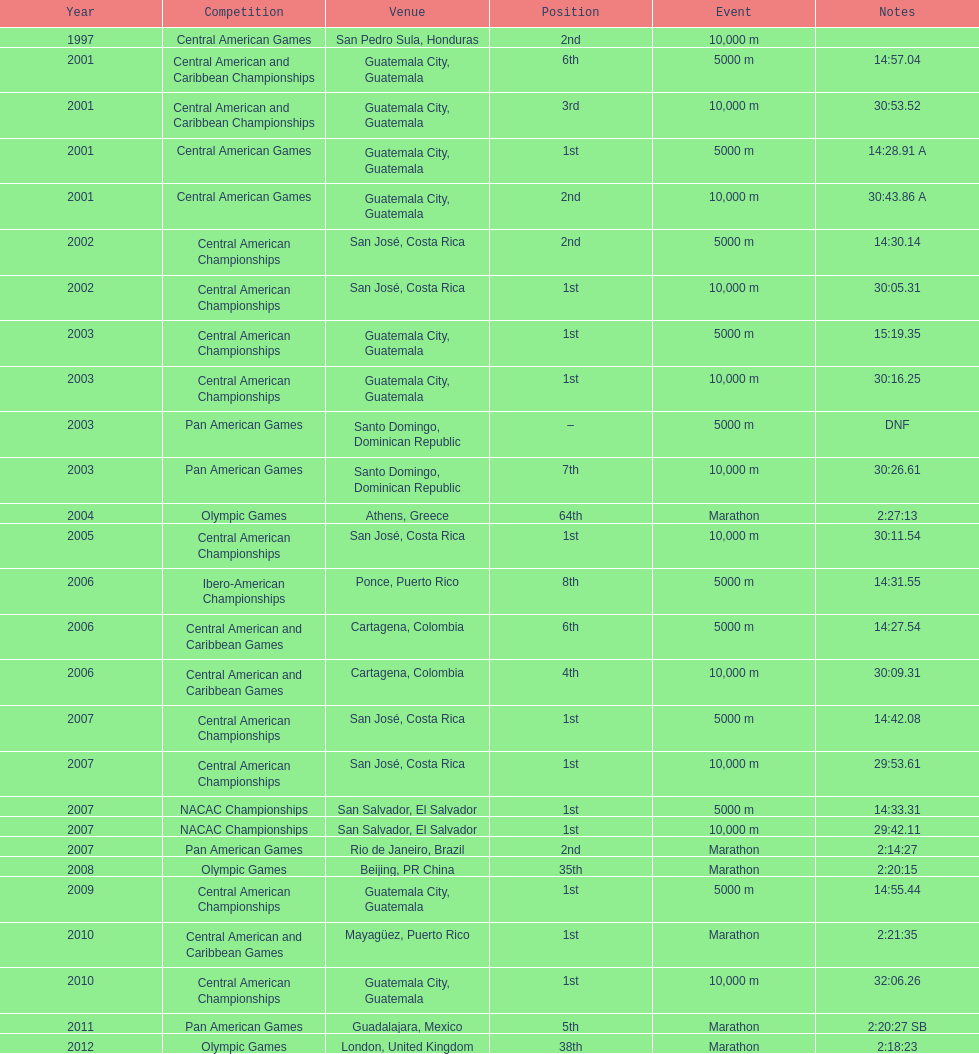How many times has this player been unable to finish a competition? 1. 